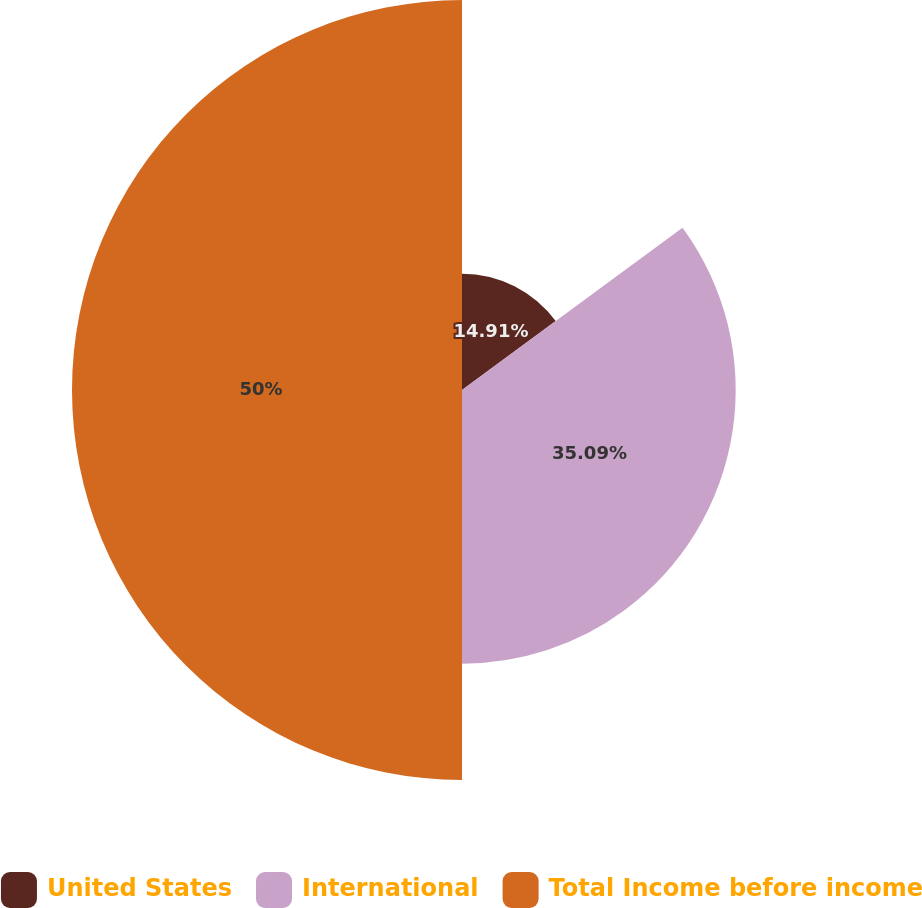<chart> <loc_0><loc_0><loc_500><loc_500><pie_chart><fcel>United States<fcel>International<fcel>Total Income before income<nl><fcel>14.91%<fcel>35.09%<fcel>50.0%<nl></chart> 